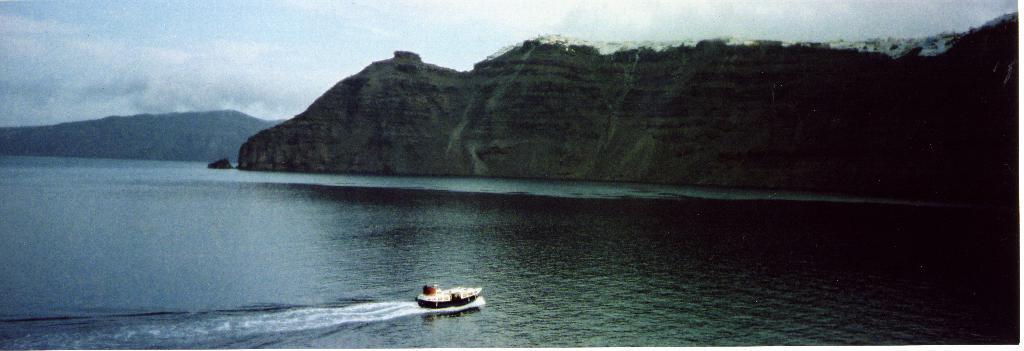How would you summarize this image in a sentence or two? This picture shows a boat in the water and we see hills and a cloudy sky. 